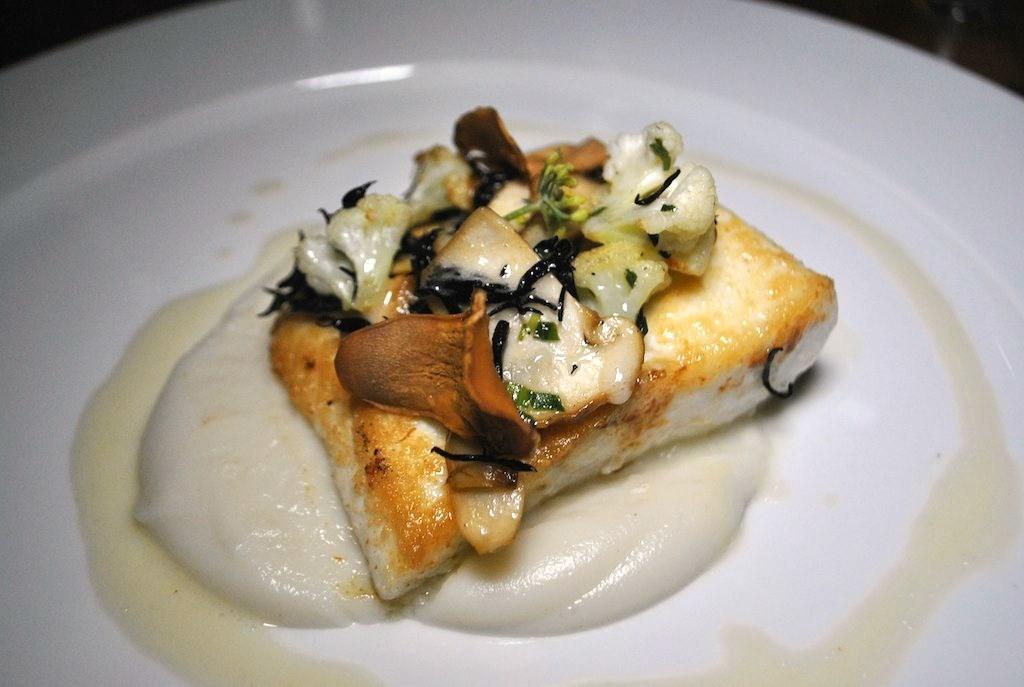Could you give a brief overview of what you see in this image? In this picture there is a food item, served in a plate. 